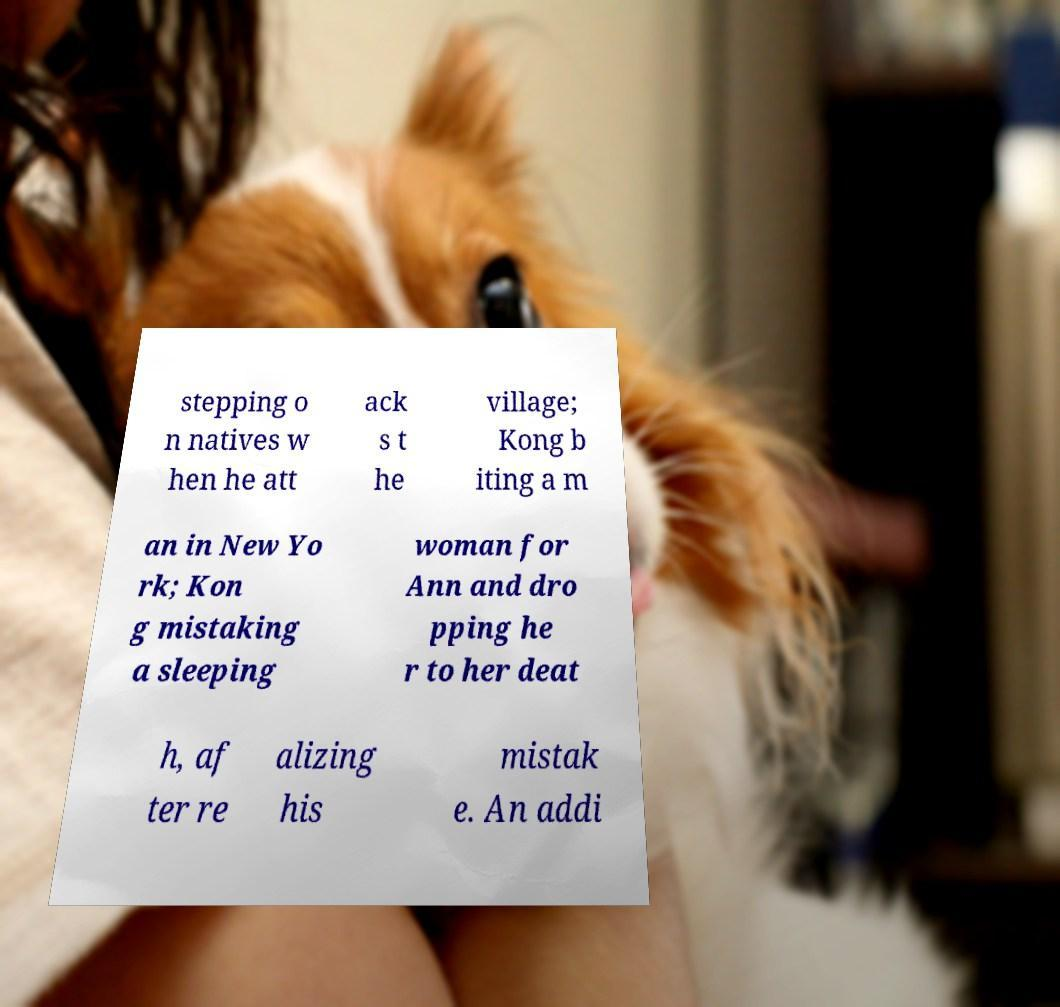Please read and relay the text visible in this image. What does it say? stepping o n natives w hen he att ack s t he village; Kong b iting a m an in New Yo rk; Kon g mistaking a sleeping woman for Ann and dro pping he r to her deat h, af ter re alizing his mistak e. An addi 